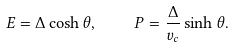Convert formula to latex. <formula><loc_0><loc_0><loc_500><loc_500>E = \Delta \cosh \theta , \quad P = \frac { \Delta } { v _ { c } } \sinh \theta .</formula> 